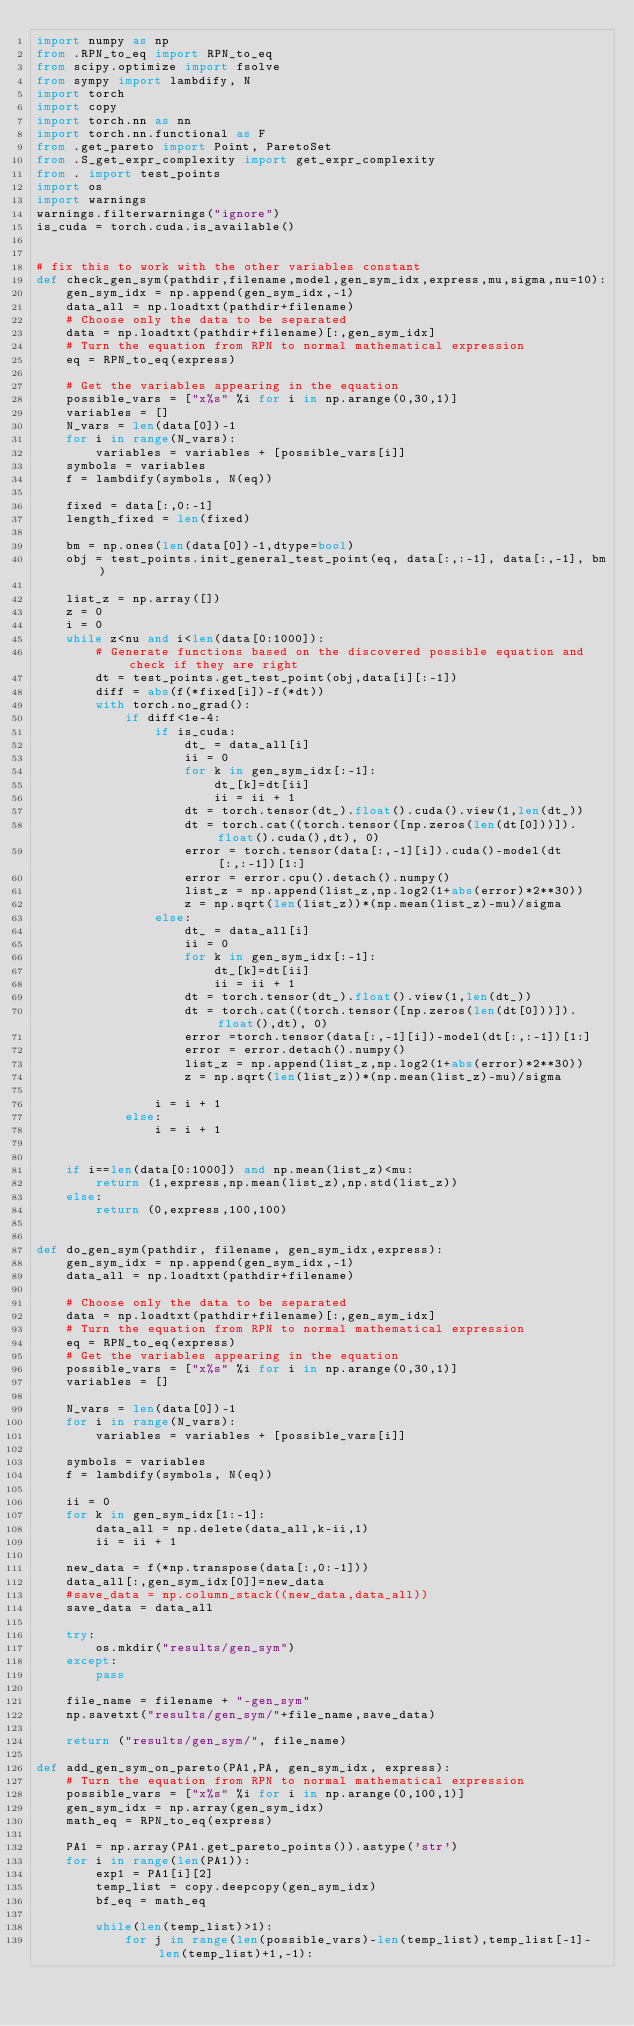Convert code to text. <code><loc_0><loc_0><loc_500><loc_500><_Python_>import numpy as np
from .RPN_to_eq import RPN_to_eq
from scipy.optimize import fsolve
from sympy import lambdify, N
import torch
import copy
import torch.nn as nn
import torch.nn.functional as F
from .get_pareto import Point, ParetoSet
from .S_get_expr_complexity import get_expr_complexity
from . import test_points
import os
import warnings
warnings.filterwarnings("ignore")
is_cuda = torch.cuda.is_available()


# fix this to work with the other variables constant
def check_gen_sym(pathdir,filename,model,gen_sym_idx,express,mu,sigma,nu=10):
    gen_sym_idx = np.append(gen_sym_idx,-1)
    data_all = np.loadtxt(pathdir+filename)
    # Choose only the data to be separated
    data = np.loadtxt(pathdir+filename)[:,gen_sym_idx]
    # Turn the equation from RPN to normal mathematical expression
    eq = RPN_to_eq(express)
    
    # Get the variables appearing in the equation
    possible_vars = ["x%s" %i for i in np.arange(0,30,1)]
    variables = []
    N_vars = len(data[0])-1
    for i in range(N_vars):
        variables = variables + [possible_vars[i]]
    symbols = variables
    f = lambdify(symbols, N(eq))

    fixed = data[:,0:-1]
    length_fixed = len(fixed)

    bm = np.ones(len(data[0])-1,dtype=bool)
    obj = test_points.init_general_test_point(eq, data[:,:-1], data[:,-1], bm)

    list_z = np.array([])
    z = 0
    i = 0
    while z<nu and i<len(data[0:1000]):
        # Generate functions based on the discovered possible equation and check if they are right
        dt = test_points.get_test_point(obj,data[i][:-1])
        diff = abs(f(*fixed[i])-f(*dt))
        with torch.no_grad():
            if diff<1e-4:
                if is_cuda:
                    dt_ = data_all[i]
                    ii = 0
                    for k in gen_sym_idx[:-1]:
                        dt_[k]=dt[ii]
                        ii = ii + 1
                    dt = torch.tensor(dt_).float().cuda().view(1,len(dt_))
                    dt = torch.cat((torch.tensor([np.zeros(len(dt[0]))]).float().cuda(),dt), 0)
                    error = torch.tensor(data[:,-1][i]).cuda()-model(dt[:,:-1])[1:]
                    error = error.cpu().detach().numpy()
                    list_z = np.append(list_z,np.log2(1+abs(error)*2**30))
                    z = np.sqrt(len(list_z))*(np.mean(list_z)-mu)/sigma
                else:
                    dt_ = data_all[i]
                    ii = 0
                    for k in gen_sym_idx[:-1]:
                        dt_[k]=dt[ii]
                        ii = ii + 1
                    dt = torch.tensor(dt_).float().view(1,len(dt_))
                    dt = torch.cat((torch.tensor([np.zeros(len(dt[0]))]).float(),dt), 0)
                    error =torch.tensor(data[:,-1][i])-model(dt[:,:-1])[1:]
                    error = error.detach().numpy()
                    list_z = np.append(list_z,np.log2(1+abs(error)*2**30))
                    z = np.sqrt(len(list_z))*(np.mean(list_z)-mu)/sigma
                    
                i = i + 1
            else:
                i = i + 1

    
    if i==len(data[0:1000]) and np.mean(list_z)<mu:
        return (1,express,np.mean(list_z),np.std(list_z))
    else:
        return (0,express,100,100)


def do_gen_sym(pathdir, filename, gen_sym_idx,express):
    gen_sym_idx = np.append(gen_sym_idx,-1)
    data_all = np.loadtxt(pathdir+filename)

    # Choose only the data to be separated
    data = np.loadtxt(pathdir+filename)[:,gen_sym_idx]
    # Turn the equation from RPN to normal mathematical expression
    eq = RPN_to_eq(express)
    # Get the variables appearing in the equation
    possible_vars = ["x%s" %i for i in np.arange(0,30,1)]
    variables = []

    N_vars = len(data[0])-1
    for i in range(N_vars):
        variables = variables + [possible_vars[i]]

    symbols = variables
    f = lambdify(symbols, N(eq))

    ii = 0
    for k in gen_sym_idx[1:-1]:
        data_all = np.delete(data_all,k-ii,1)
        ii = ii + 1

    new_data = f(*np.transpose(data[:,0:-1]))
    data_all[:,gen_sym_idx[0]]=new_data
    #save_data = np.column_stack((new_data,data_all))
    save_data = data_all

    try:
        os.mkdir("results/gen_sym")
    except:
        pass

    file_name = filename + "-gen_sym"
    np.savetxt("results/gen_sym/"+file_name,save_data)

    return ("results/gen_sym/", file_name)

def add_gen_sym_on_pareto(PA1,PA, gen_sym_idx, express):
    # Turn the equation from RPN to normal mathematical expression
    possible_vars = ["x%s" %i for i in np.arange(0,100,1)]
    gen_sym_idx = np.array(gen_sym_idx)
    math_eq = RPN_to_eq(express)

    PA1 = np.array(PA1.get_pareto_points()).astype('str')
    for i in range(len(PA1)):
        exp1 = PA1[i][2]
        temp_list = copy.deepcopy(gen_sym_idx)
        bf_eq = math_eq
        
        while(len(temp_list)>1):
            for j in range(len(possible_vars)-len(temp_list),temp_list[-1]-len(temp_list)+1,-1):</code> 